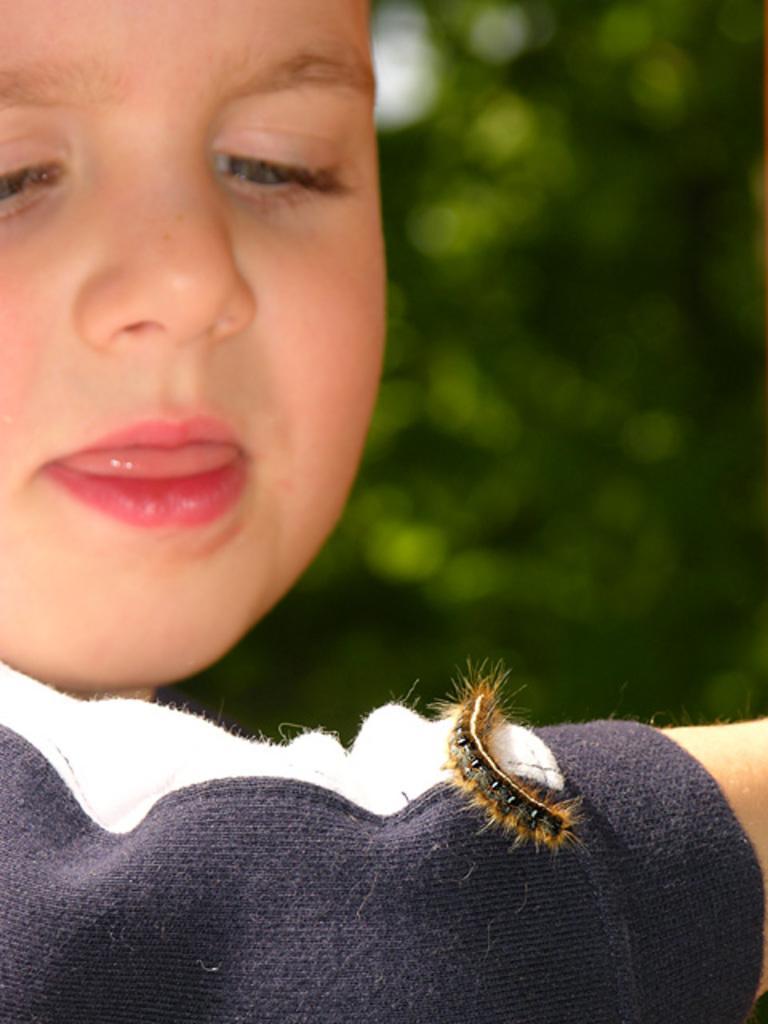Could you give a brief overview of what you see in this image? In this image we can see a boy and we can also see the caterpillar on the hand. The background is blurred. 